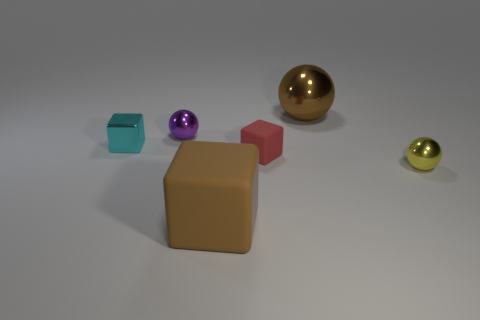Add 2 big cyan things. How many objects exist? 8 Subtract all matte blocks. How many blocks are left? 1 Subtract 2 spheres. How many spheres are left? 1 Subtract all brown cubes. How many cubes are left? 2 Subtract all cylinders. Subtract all small cyan cubes. How many objects are left? 5 Add 4 big things. How many big things are left? 6 Add 4 metal spheres. How many metal spheres exist? 7 Subtract 1 brown balls. How many objects are left? 5 Subtract all purple balls. Subtract all yellow cylinders. How many balls are left? 2 Subtract all red cylinders. How many green spheres are left? 0 